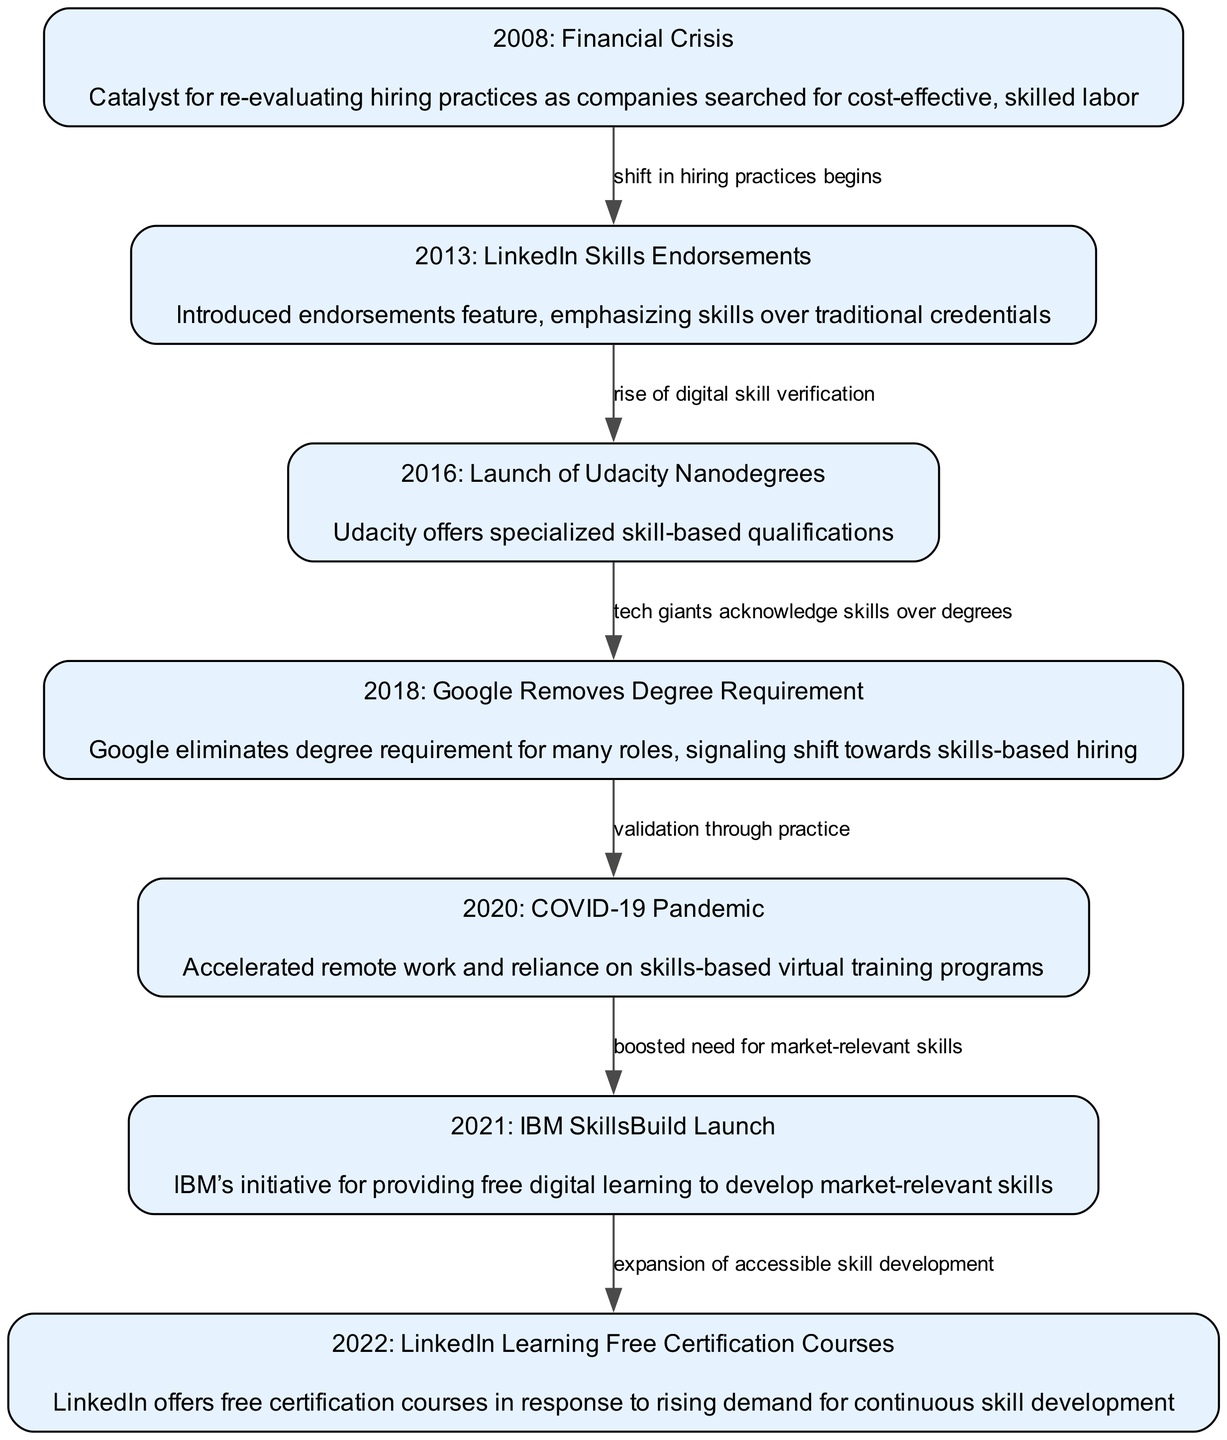What is the first milestone in the timeline? The first milestone listed in the timeline is "2008: Financial Crisis". This information can be found in the node that represents the year 2008, which highlights the financial crisis as a catalyst for re-evaluating hiring practices.
Answer: 2008: Financial Crisis How many nodes are in the diagram? The diagram contains a total of 7 nodes, each representing a significant milestone related to skills-based hiring practices over the last decade. This can be counted directly from the nodes section of the data provided.
Answer: 7 What was introduced in 2013? In 2013, "LinkedIn Skills Endorsements" were introduced, which is specifically noted in the node for that year as emphasizing skills over traditional credentials.
Answer: LinkedIn Skills Endorsements What shift occurred in 2018? In 2018, "Google Removes Degree Requirement" marked a significant shift towards skills-based hiring, as indicated in the description of that node.
Answer: Google Removes Degree Requirement What connection does the 2008 node have? The 2008 node has a direct connection to the 2013 node, indicating that the shift in hiring practices began after the financial crisis. This relationship is explicitly described by the edge connecting these two nodes.
Answer: Shift in hiring practices begins What was the response to the COVID-19 pandemic in 2020? The response to the COVID-19 pandemic in 2020 was an "Accelerated remote work and reliance on skills-based virtual training programs", highlighting how the pandemic influenced hiring practices. This information is provided in the node for 2020.
Answer: Accelerated remote work and reliance on skills-based virtual training programs What did IBM launch in 2021? IBM launched "SkillsBuild" in 2021, which is highlighted in the node for that year as an initiative for providing free digital learning aimed at developing market-relevant skills.
Answer: SkillsBuild What does the edge from 2020 to 2021 denote? The edge from 2020 to 2021 denotes "boosted need for market-relevant skills", indicating that the events of 2020 led to an increased emphasis on skills needed in the market. This is shown in the labeling of the edge connecting those two nodes.
Answer: Boosted need for market-relevant skills 